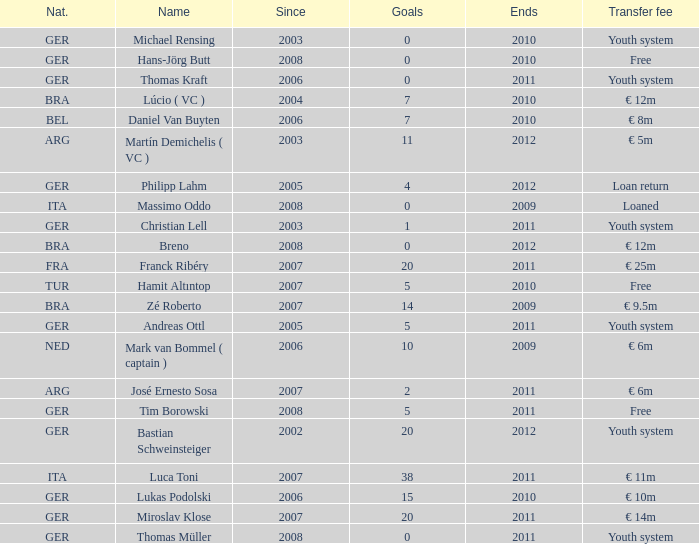Would you mind parsing the complete table? {'header': ['Nat.', 'Name', 'Since', 'Goals', 'Ends', 'Transfer fee'], 'rows': [['GER', 'Michael Rensing', '2003', '0', '2010', 'Youth system'], ['GER', 'Hans-Jörg Butt', '2008', '0', '2010', 'Free'], ['GER', 'Thomas Kraft', '2006', '0', '2011', 'Youth system'], ['BRA', 'Lúcio ( VC )', '2004', '7', '2010', '€ 12m'], ['BEL', 'Daniel Van Buyten', '2006', '7', '2010', '€ 8m'], ['ARG', 'Martín Demichelis ( VC )', '2003', '11', '2012', '€ 5m'], ['GER', 'Philipp Lahm', '2005', '4', '2012', 'Loan return'], ['ITA', 'Massimo Oddo', '2008', '0', '2009', 'Loaned'], ['GER', 'Christian Lell', '2003', '1', '2011', 'Youth system'], ['BRA', 'Breno', '2008', '0', '2012', '€ 12m'], ['FRA', 'Franck Ribéry', '2007', '20', '2011', '€ 25m'], ['TUR', 'Hamit Altıntop', '2007', '5', '2010', 'Free'], ['BRA', 'Zé Roberto', '2007', '14', '2009', '€ 9.5m'], ['GER', 'Andreas Ottl', '2005', '5', '2011', 'Youth system'], ['NED', 'Mark van Bommel ( captain )', '2006', '10', '2009', '€ 6m'], ['ARG', 'José Ernesto Sosa', '2007', '2', '2011', '€ 6m'], ['GER', 'Tim Borowski', '2008', '5', '2011', 'Free'], ['GER', 'Bastian Schweinsteiger', '2002', '20', '2012', 'Youth system'], ['ITA', 'Luca Toni', '2007', '38', '2011', '€ 11m'], ['GER', 'Lukas Podolski', '2006', '15', '2010', '€ 10m'], ['GER', 'Miroslav Klose', '2007', '20', '2011', '€ 14m'], ['GER', 'Thomas Müller', '2008', '0', '2011', 'Youth system']]} After 2006, what is the count of individuals with italian nationality who scored 0 goals? 0.0. 